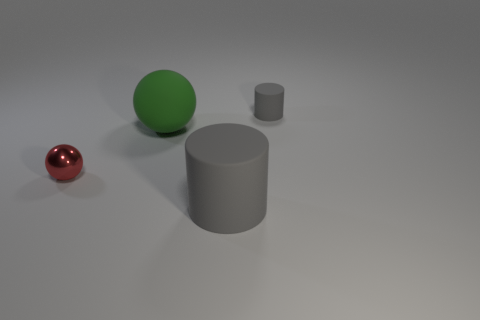There is a tiny matte object; is its color the same as the matte object in front of the green object?
Offer a terse response. Yes. What color is the small shiny sphere?
Make the answer very short. Red. There is another object that is the same shape as the green rubber object; what is its color?
Keep it short and to the point. Red. Does the tiny red metallic object have the same shape as the small gray rubber thing?
Ensure brevity in your answer.  No. How many spheres are either large matte things or tiny metallic things?
Give a very brief answer. 2. There is another cylinder that is made of the same material as the small cylinder; what color is it?
Your answer should be very brief. Gray. There is a rubber cylinder in front of the shiny object; is it the same size as the tiny red sphere?
Your answer should be compact. No. Does the tiny red ball have the same material as the cylinder in front of the tiny gray object?
Your response must be concise. No. What is the color of the cylinder in front of the small metal thing?
Give a very brief answer. Gray. There is a gray thing left of the tiny gray cylinder; is there a gray rubber thing behind it?
Keep it short and to the point. Yes. 